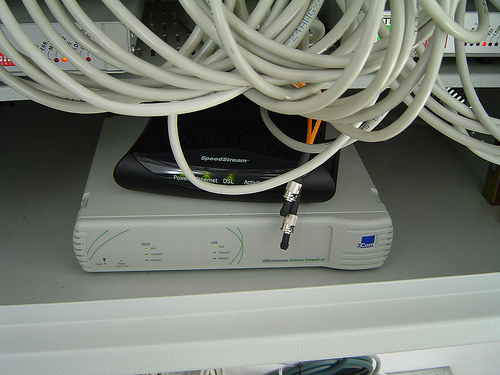<image>
Is the electronic device under the wires? Yes. The electronic device is positioned underneath the wires, with the wires above it in the vertical space. 